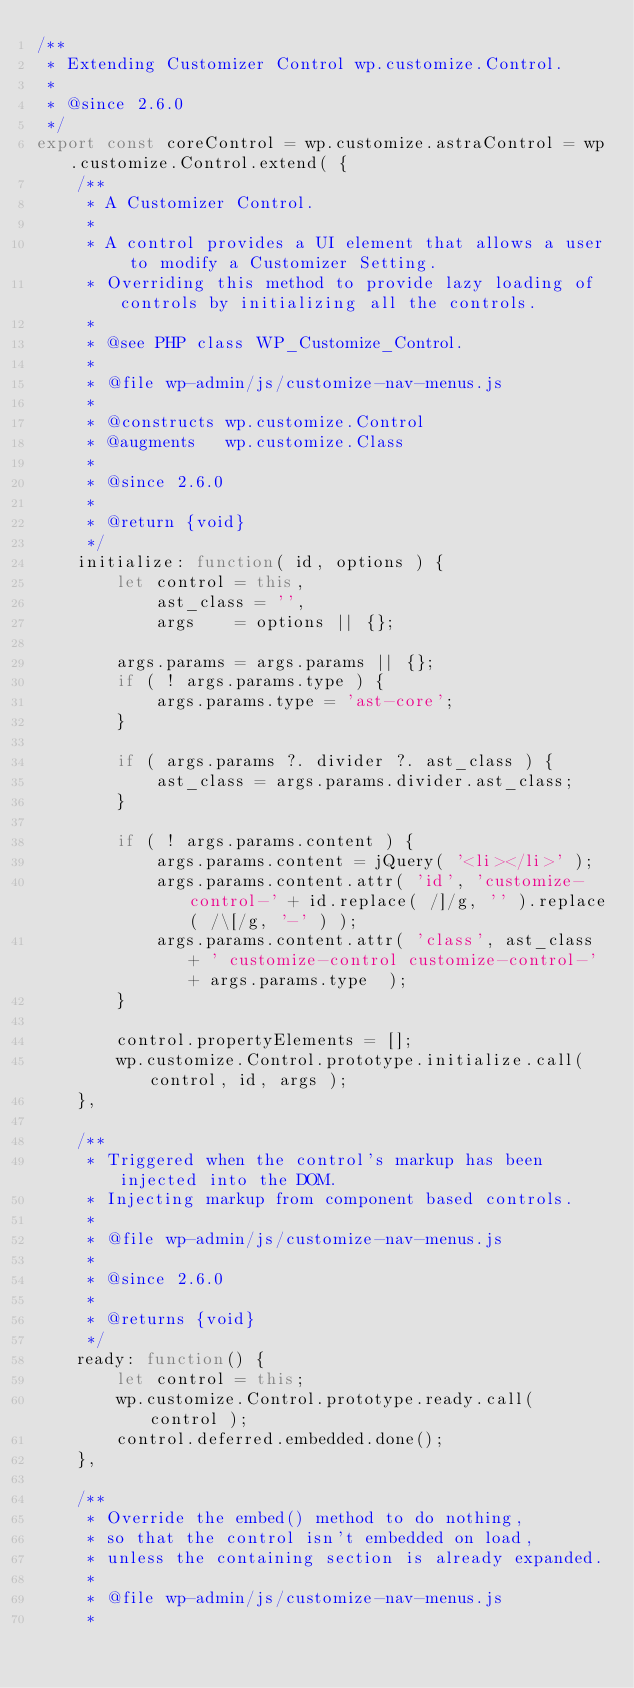Convert code to text. <code><loc_0><loc_0><loc_500><loc_500><_JavaScript_>/**
 * Extending Customizer Control wp.customize.Control.
 *
 * @since 2.6.0
 */
export const coreControl = wp.customize.astraControl = wp.customize.Control.extend( {
	/**
	 * A Customizer Control.
	 *
	 * A control provides a UI element that allows a user to modify a Customizer Setting.
	 * Overriding this method to provide lazy loading of controls by initializing all the controls.
	 *
	 * @see PHP class WP_Customize_Control.
	 *
	 * @file wp-admin/js/customize-nav-menus.js
	 *
	 * @constructs wp.customize.Control
	 * @augments   wp.customize.Class
	 *
	 * @since 2.6.0
	 *
	 * @return {void}
	 */
	initialize: function( id, options ) {
		let control = this,
			ast_class = '',
			args    = options || {};

		args.params = args.params || {};
		if ( ! args.params.type ) {
			args.params.type = 'ast-core';
		}

		if ( args.params ?. divider ?. ast_class ) {
			ast_class = args.params.divider.ast_class;
		}

		if ( ! args.params.content ) {
			args.params.content = jQuery( '<li></li>' );
			args.params.content.attr( 'id', 'customize-control-' + id.replace( /]/g, '' ).replace( /\[/g, '-' ) );
			args.params.content.attr( 'class', ast_class + ' customize-control customize-control-' + args.params.type  );
		}

		control.propertyElements = [];
		wp.customize.Control.prototype.initialize.call( control, id, args );
	},

	/**
	 * Triggered when the control's markup has been injected into the DOM.
	 * Injecting markup from component based controls.
	 *
	 * @file wp-admin/js/customize-nav-menus.js
	 *
	 * @since 2.6.0
	 *
	 * @returns {void}
	 */
	ready: function() {
		let control = this;
		wp.customize.Control.prototype.ready.call( control );
		control.deferred.embedded.done();
	},

	/**
	 * Override the embed() method to do nothing,
	 * so that the control isn't embedded on load,
	 * unless the containing section is already expanded.
	 *
	 * @file wp-admin/js/customize-nav-menus.js
	 *</code> 